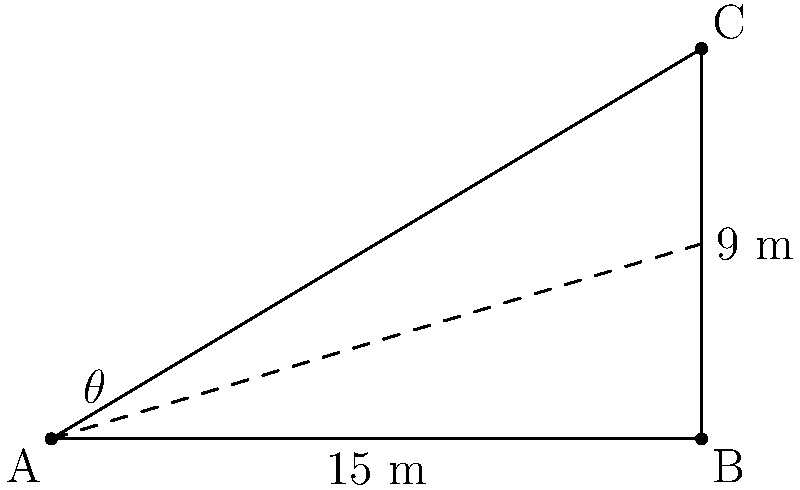While researching Soviet-era monuments for your documentary, you come across the iconic "Worker and Kolkhoz Woman" statue in Moscow. To capture its imposing nature, you want to determine the angle of inclination of the statue. If the base of the statue is 15 meters wide and its height is 9 meters, what is the angle of inclination ($\theta$) from the ground to the top of the statue? To find the angle of inclination, we can use the trigonometric function tangent. Here's how to solve this step-by-step:

1) In a right triangle, tangent of an angle is the ratio of the opposite side to the adjacent side.

2) In this case:
   - The opposite side is the height of the statue: 9 meters
   - The adjacent side is half the width of the base: 15/2 = 7.5 meters

3) We can express this as:

   $$\tan(\theta) = \frac{\text{opposite}}{\text{adjacent}} = \frac{9}{7.5}$$

4) To find $\theta$, we need to use the inverse tangent (arctangent) function:

   $$\theta = \arctan(\frac{9}{7.5})$$

5) Calculate this value:
   
   $$\theta = \arctan(1.2) \approx 50.2°$$

6) Round to the nearest degree:

   $$\theta \approx 50°$$

Therefore, the angle of inclination of the statue is approximately 50 degrees.
Answer: $50°$ 